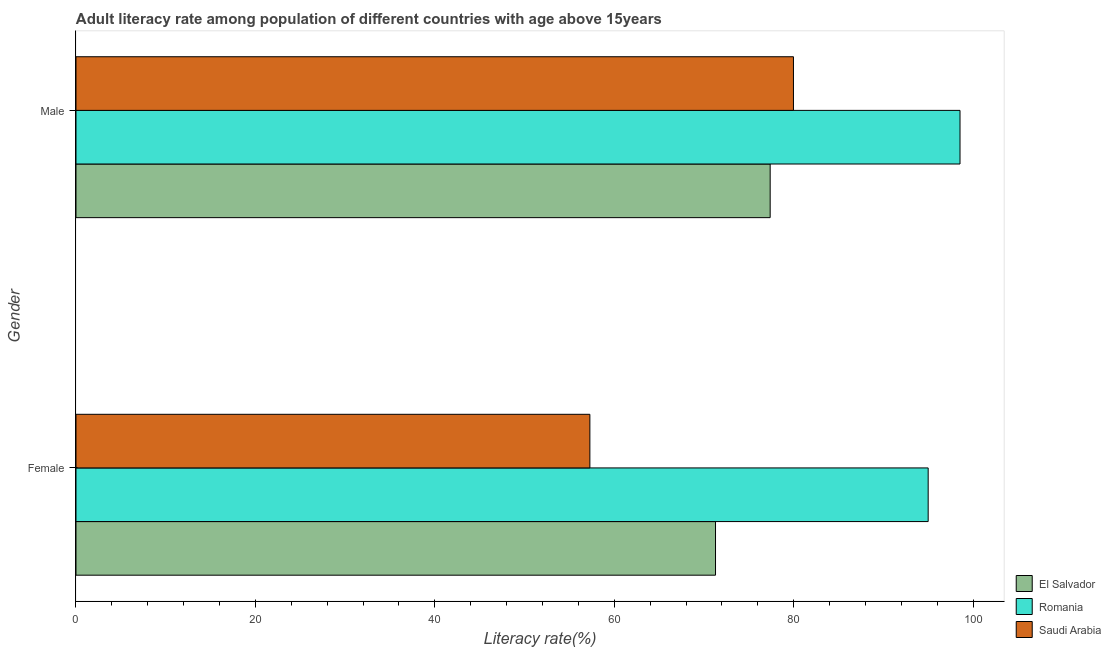How many different coloured bars are there?
Make the answer very short. 3. How many groups of bars are there?
Your response must be concise. 2. How many bars are there on the 1st tick from the top?
Your answer should be very brief. 3. What is the female adult literacy rate in Saudi Arabia?
Keep it short and to the point. 57.28. Across all countries, what is the maximum male adult literacy rate?
Keep it short and to the point. 98.53. Across all countries, what is the minimum female adult literacy rate?
Your answer should be very brief. 57.28. In which country was the female adult literacy rate maximum?
Give a very brief answer. Romania. In which country was the female adult literacy rate minimum?
Give a very brief answer. Saudi Arabia. What is the total male adult literacy rate in the graph?
Keep it short and to the point. 255.87. What is the difference between the female adult literacy rate in El Salvador and that in Romania?
Provide a succinct answer. -23.7. What is the difference between the male adult literacy rate in El Salvador and the female adult literacy rate in Saudi Arabia?
Ensure brevity in your answer.  20.09. What is the average female adult literacy rate per country?
Make the answer very short. 74.51. What is the difference between the male adult literacy rate and female adult literacy rate in Romania?
Ensure brevity in your answer.  3.55. In how many countries, is the male adult literacy rate greater than 28 %?
Keep it short and to the point. 3. What is the ratio of the female adult literacy rate in Saudi Arabia to that in El Salvador?
Give a very brief answer. 0.8. Is the female adult literacy rate in Romania less than that in El Salvador?
Offer a very short reply. No. In how many countries, is the male adult literacy rate greater than the average male adult literacy rate taken over all countries?
Provide a short and direct response. 1. What does the 3rd bar from the top in Female represents?
Keep it short and to the point. El Salvador. What does the 2nd bar from the bottom in Female represents?
Keep it short and to the point. Romania. How many bars are there?
Offer a terse response. 6. Are all the bars in the graph horizontal?
Offer a terse response. Yes. What is the difference between two consecutive major ticks on the X-axis?
Provide a succinct answer. 20. Are the values on the major ticks of X-axis written in scientific E-notation?
Your response must be concise. No. Does the graph contain any zero values?
Keep it short and to the point. No. Where does the legend appear in the graph?
Keep it short and to the point. Bottom right. How many legend labels are there?
Make the answer very short. 3. How are the legend labels stacked?
Offer a terse response. Vertical. What is the title of the graph?
Offer a terse response. Adult literacy rate among population of different countries with age above 15years. Does "Lithuania" appear as one of the legend labels in the graph?
Give a very brief answer. No. What is the label or title of the X-axis?
Give a very brief answer. Literacy rate(%). What is the label or title of the Y-axis?
Ensure brevity in your answer.  Gender. What is the Literacy rate(%) of El Salvador in Female?
Your response must be concise. 71.28. What is the Literacy rate(%) of Romania in Female?
Offer a very short reply. 94.98. What is the Literacy rate(%) in Saudi Arabia in Female?
Offer a very short reply. 57.28. What is the Literacy rate(%) in El Salvador in Male?
Keep it short and to the point. 77.37. What is the Literacy rate(%) in Romania in Male?
Make the answer very short. 98.53. What is the Literacy rate(%) of Saudi Arabia in Male?
Offer a very short reply. 79.97. Across all Gender, what is the maximum Literacy rate(%) in El Salvador?
Provide a short and direct response. 77.37. Across all Gender, what is the maximum Literacy rate(%) in Romania?
Make the answer very short. 98.53. Across all Gender, what is the maximum Literacy rate(%) in Saudi Arabia?
Ensure brevity in your answer.  79.97. Across all Gender, what is the minimum Literacy rate(%) of El Salvador?
Give a very brief answer. 71.28. Across all Gender, what is the minimum Literacy rate(%) of Romania?
Your answer should be very brief. 94.98. Across all Gender, what is the minimum Literacy rate(%) in Saudi Arabia?
Your answer should be compact. 57.28. What is the total Literacy rate(%) of El Salvador in the graph?
Provide a succinct answer. 148.65. What is the total Literacy rate(%) in Romania in the graph?
Your answer should be compact. 193.51. What is the total Literacy rate(%) in Saudi Arabia in the graph?
Provide a succinct answer. 137.25. What is the difference between the Literacy rate(%) of El Salvador in Female and that in Male?
Give a very brief answer. -6.09. What is the difference between the Literacy rate(%) in Romania in Female and that in Male?
Make the answer very short. -3.55. What is the difference between the Literacy rate(%) in Saudi Arabia in Female and that in Male?
Your answer should be compact. -22.69. What is the difference between the Literacy rate(%) of El Salvador in Female and the Literacy rate(%) of Romania in Male?
Keep it short and to the point. -27.25. What is the difference between the Literacy rate(%) of El Salvador in Female and the Literacy rate(%) of Saudi Arabia in Male?
Your answer should be compact. -8.69. What is the difference between the Literacy rate(%) of Romania in Female and the Literacy rate(%) of Saudi Arabia in Male?
Your answer should be very brief. 15.01. What is the average Literacy rate(%) of El Salvador per Gender?
Your answer should be compact. 74.33. What is the average Literacy rate(%) of Romania per Gender?
Offer a very short reply. 96.76. What is the average Literacy rate(%) in Saudi Arabia per Gender?
Make the answer very short. 68.62. What is the difference between the Literacy rate(%) of El Salvador and Literacy rate(%) of Romania in Female?
Ensure brevity in your answer.  -23.7. What is the difference between the Literacy rate(%) of El Salvador and Literacy rate(%) of Saudi Arabia in Female?
Your answer should be very brief. 14. What is the difference between the Literacy rate(%) in Romania and Literacy rate(%) in Saudi Arabia in Female?
Offer a terse response. 37.7. What is the difference between the Literacy rate(%) in El Salvador and Literacy rate(%) in Romania in Male?
Ensure brevity in your answer.  -21.16. What is the difference between the Literacy rate(%) in El Salvador and Literacy rate(%) in Saudi Arabia in Male?
Make the answer very short. -2.6. What is the difference between the Literacy rate(%) of Romania and Literacy rate(%) of Saudi Arabia in Male?
Your answer should be very brief. 18.56. What is the ratio of the Literacy rate(%) in El Salvador in Female to that in Male?
Your answer should be very brief. 0.92. What is the ratio of the Literacy rate(%) in Romania in Female to that in Male?
Make the answer very short. 0.96. What is the ratio of the Literacy rate(%) in Saudi Arabia in Female to that in Male?
Give a very brief answer. 0.72. What is the difference between the highest and the second highest Literacy rate(%) in El Salvador?
Your response must be concise. 6.09. What is the difference between the highest and the second highest Literacy rate(%) in Romania?
Offer a terse response. 3.55. What is the difference between the highest and the second highest Literacy rate(%) of Saudi Arabia?
Provide a succinct answer. 22.69. What is the difference between the highest and the lowest Literacy rate(%) of El Salvador?
Give a very brief answer. 6.09. What is the difference between the highest and the lowest Literacy rate(%) of Romania?
Your answer should be compact. 3.55. What is the difference between the highest and the lowest Literacy rate(%) of Saudi Arabia?
Your response must be concise. 22.69. 